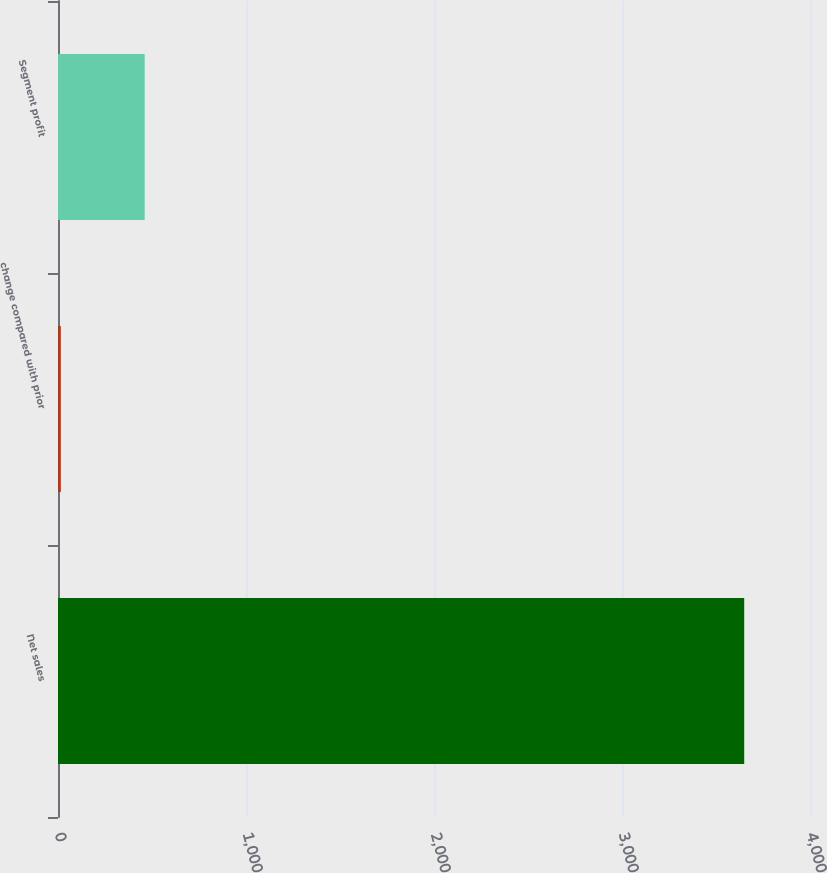Convert chart. <chart><loc_0><loc_0><loc_500><loc_500><bar_chart><fcel>Net sales<fcel>change compared with prior<fcel>Segment profit<nl><fcel>3650<fcel>15<fcel>461<nl></chart> 